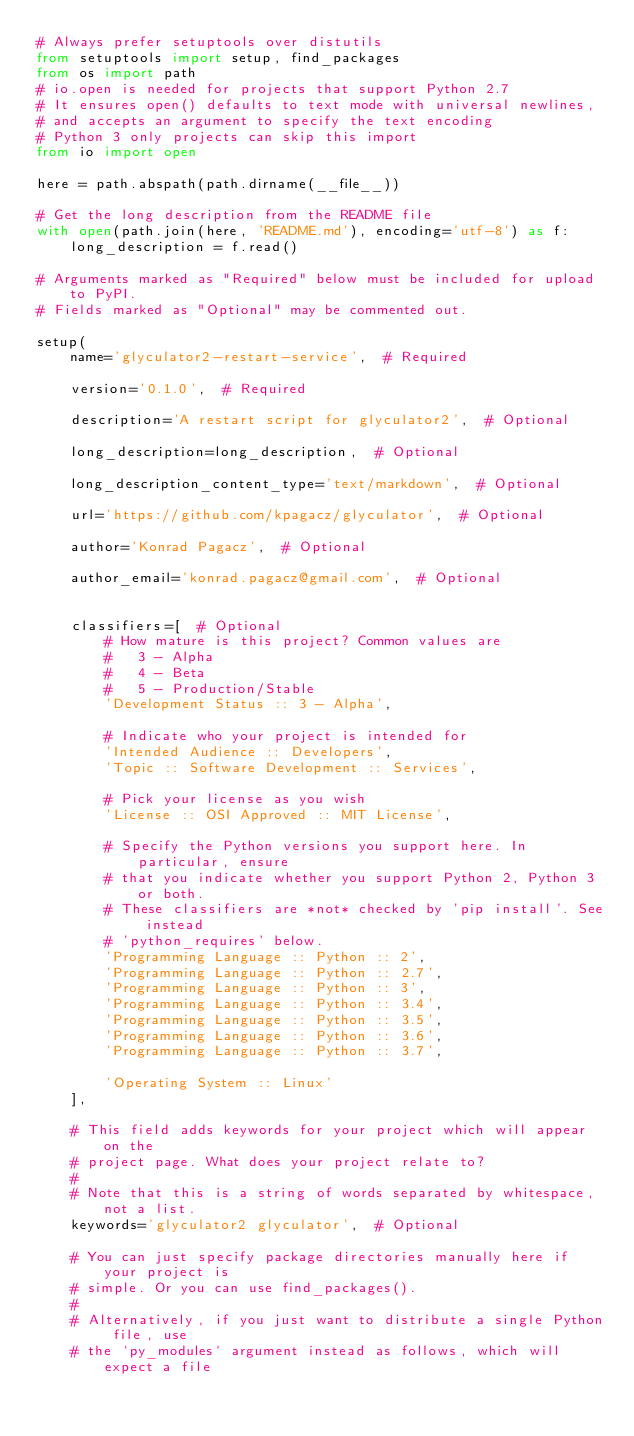Convert code to text. <code><loc_0><loc_0><loc_500><loc_500><_Python_># Always prefer setuptools over distutils
from setuptools import setup, find_packages
from os import path
# io.open is needed for projects that support Python 2.7
# It ensures open() defaults to text mode with universal newlines,
# and accepts an argument to specify the text encoding
# Python 3 only projects can skip this import
from io import open

here = path.abspath(path.dirname(__file__))

# Get the long description from the README file
with open(path.join(here, 'README.md'), encoding='utf-8') as f:
    long_description = f.read()

# Arguments marked as "Required" below must be included for upload to PyPI.
# Fields marked as "Optional" may be commented out.

setup(
    name='glyculator2-restart-service',  # Required

    version='0.1.0',  # Required

    description='A restart script for glyculator2',  # Optional

    long_description=long_description,  # Optional

    long_description_content_type='text/markdown',  # Optional

    url='https://github.com/kpagacz/glyculator',  # Optional

    author='Konrad Pagacz',  # Optional

    author_email='konrad.pagacz@gmail.com',  # Optional


    classifiers=[  # Optional
        # How mature is this project? Common values are
        #   3 - Alpha
        #   4 - Beta
        #   5 - Production/Stable
        'Development Status :: 3 - Alpha',

        # Indicate who your project is intended for
        'Intended Audience :: Developers',
        'Topic :: Software Development :: Services',

        # Pick your license as you wish
        'License :: OSI Approved :: MIT License',

        # Specify the Python versions you support here. In particular, ensure
        # that you indicate whether you support Python 2, Python 3 or both.
        # These classifiers are *not* checked by 'pip install'. See instead
        # 'python_requires' below.
        'Programming Language :: Python :: 2',
        'Programming Language :: Python :: 2.7',
        'Programming Language :: Python :: 3',
        'Programming Language :: Python :: 3.4',
        'Programming Language :: Python :: 3.5',
        'Programming Language :: Python :: 3.6',
        'Programming Language :: Python :: 3.7',

        'Operating System :: Linux'
    ],

    # This field adds keywords for your project which will appear on the
    # project page. What does your project relate to?
    #
    # Note that this is a string of words separated by whitespace, not a list.
    keywords='glyculator2 glyculator',  # Optional

    # You can just specify package directories manually here if your project is
    # simple. Or you can use find_packages().
    #
    # Alternatively, if you just want to distribute a single Python file, use
    # the `py_modules` argument instead as follows, which will expect a file</code> 